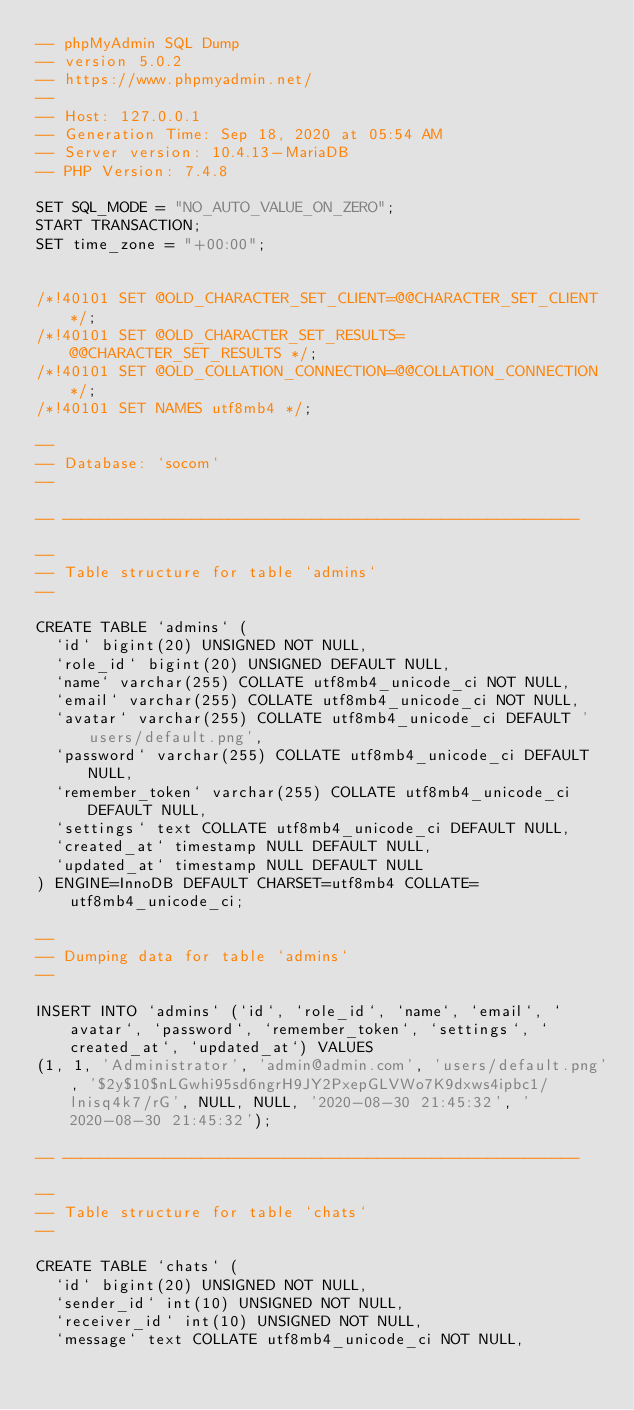Convert code to text. <code><loc_0><loc_0><loc_500><loc_500><_SQL_>-- phpMyAdmin SQL Dump
-- version 5.0.2
-- https://www.phpmyadmin.net/
--
-- Host: 127.0.0.1
-- Generation Time: Sep 18, 2020 at 05:54 AM
-- Server version: 10.4.13-MariaDB
-- PHP Version: 7.4.8

SET SQL_MODE = "NO_AUTO_VALUE_ON_ZERO";
START TRANSACTION;
SET time_zone = "+00:00";


/*!40101 SET @OLD_CHARACTER_SET_CLIENT=@@CHARACTER_SET_CLIENT */;
/*!40101 SET @OLD_CHARACTER_SET_RESULTS=@@CHARACTER_SET_RESULTS */;
/*!40101 SET @OLD_COLLATION_CONNECTION=@@COLLATION_CONNECTION */;
/*!40101 SET NAMES utf8mb4 */;

--
-- Database: `socom`
--

-- --------------------------------------------------------

--
-- Table structure for table `admins`
--

CREATE TABLE `admins` (
  `id` bigint(20) UNSIGNED NOT NULL,
  `role_id` bigint(20) UNSIGNED DEFAULT NULL,
  `name` varchar(255) COLLATE utf8mb4_unicode_ci NOT NULL,
  `email` varchar(255) COLLATE utf8mb4_unicode_ci NOT NULL,
  `avatar` varchar(255) COLLATE utf8mb4_unicode_ci DEFAULT 'users/default.png',
  `password` varchar(255) COLLATE utf8mb4_unicode_ci DEFAULT NULL,
  `remember_token` varchar(255) COLLATE utf8mb4_unicode_ci DEFAULT NULL,
  `settings` text COLLATE utf8mb4_unicode_ci DEFAULT NULL,
  `created_at` timestamp NULL DEFAULT NULL,
  `updated_at` timestamp NULL DEFAULT NULL
) ENGINE=InnoDB DEFAULT CHARSET=utf8mb4 COLLATE=utf8mb4_unicode_ci;

--
-- Dumping data for table `admins`
--

INSERT INTO `admins` (`id`, `role_id`, `name`, `email`, `avatar`, `password`, `remember_token`, `settings`, `created_at`, `updated_at`) VALUES
(1, 1, 'Administrator', 'admin@admin.com', 'users/default.png', '$2y$10$nLGwhi95sd6ngrH9JY2PxepGLVWo7K9dxws4ipbc1/lnisq4k7/rG', NULL, NULL, '2020-08-30 21:45:32', '2020-08-30 21:45:32');

-- --------------------------------------------------------

--
-- Table structure for table `chats`
--

CREATE TABLE `chats` (
  `id` bigint(20) UNSIGNED NOT NULL,
  `sender_id` int(10) UNSIGNED NOT NULL,
  `receiver_id` int(10) UNSIGNED NOT NULL,
  `message` text COLLATE utf8mb4_unicode_ci NOT NULL,</code> 